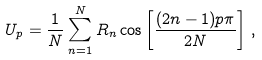Convert formula to latex. <formula><loc_0><loc_0><loc_500><loc_500>U _ { p } = \frac { 1 } { N } \sum _ { n = 1 } ^ { N } R _ { n } \cos \left [ \frac { ( 2 n - 1 ) p \pi } { 2 N } \right ] \, ,</formula> 